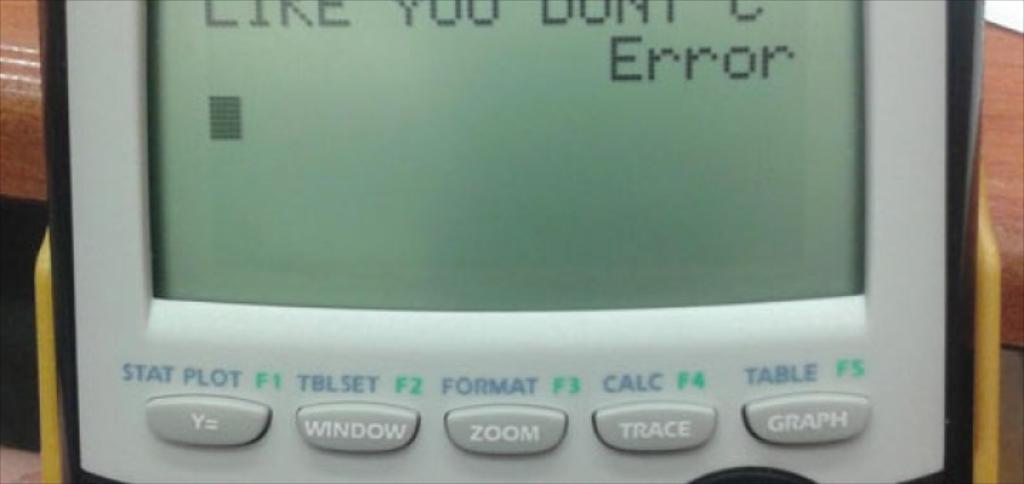<image>
Create a compact narrative representing the image presented. A calculator displays the word "Error" on the screen. 